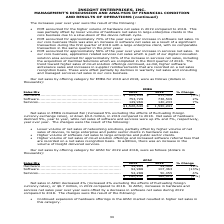From Insight Enterprises's financial document, What was the net sales of hardware in 2019 and 2018 respectively? The document shows two values: $622,949 and $653,499 (in thousands). From the document: "..................................... $ 622,949 $ 653,499 (5%) Software .................................................................. 753,729 736..." Also, What was the net sales of software in 2019 and 2018 respectively? The document shows two values: 753,729 and 736,509 (in thousands). From the document: "................................................. 753,729 736,509 2% Services................................................................... 149,9..." Also, What was the net sales of services in 2019 and 2018 respectively? The document shows two values: 149,966 and 140,233 (in thousands). From the document: "................................................. 149,966 140,233 7% $1,526,644 $ 1,530,241 — ......................................... 149,966 140,23..." Also, can you calculate: What is the change in Sales Mix of Hardware between 2018 and 2019? Based on the calculation: 622,949-653,499, the result is -30550 (in thousands). This is based on the information: "............................................... $ 622,949 $ 653,499 (5%) Software .................................................................. 753,729 ..................................... $ 622..." The key data points involved are: 622,949, 653,499. Also, can you calculate: What is the change in Sales Mix of Software between 2018 and 2019? Based on the calculation: 753,729-736,509, the result is 17220 (in thousands). This is based on the information: "................................................. 753,729 736,509 2% Services................................................................... 149,966 140, ......................................... ..." The key data points involved are: 736,509, 753,729. Also, can you calculate: What is the average Sales Mix of Hardware for 2018 and 2019? To answer this question, I need to perform calculations using the financial data. The calculation is: (622,949+653,499) / 2, which equals 638224 (in thousands). This is based on the information: "............................................... $ 622,949 $ 653,499 (5%) Software .................................................................. 753,729 ..................................... $ 622..." The key data points involved are: 622,949, 653,499. 